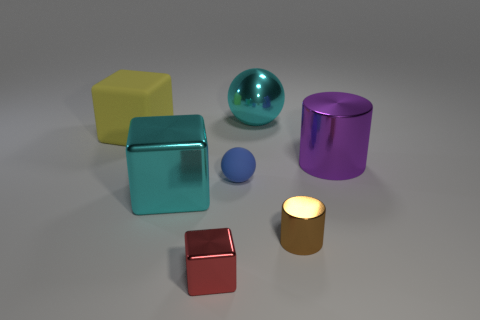There is a cylinder in front of the small matte thing; what is its material?
Keep it short and to the point. Metal. What number of other things are there of the same size as the brown cylinder?
Ensure brevity in your answer.  2. There is a purple object; is it the same size as the thing that is on the left side of the large cyan shiny cube?
Offer a terse response. Yes. There is a rubber thing that is right of the large cyan metal thing that is in front of the big metal object that is behind the big yellow block; what is its shape?
Offer a terse response. Sphere. Is the number of big objects less than the number of red things?
Make the answer very short. No. There is a large yellow matte thing; are there any small red objects left of it?
Your answer should be compact. No. There is a object that is both to the right of the small sphere and behind the big metallic cylinder; what shape is it?
Ensure brevity in your answer.  Sphere. Is there a red shiny thing that has the same shape as the tiny blue thing?
Ensure brevity in your answer.  No. Does the red thing that is left of the large purple shiny object have the same size as the object that is behind the rubber cube?
Your answer should be compact. No. Is the number of blue metal cubes greater than the number of brown objects?
Keep it short and to the point. No. 